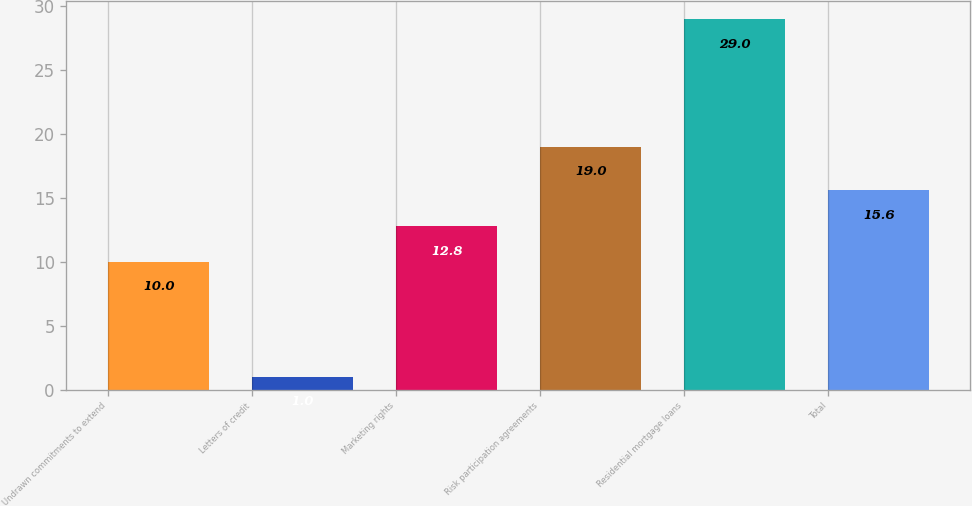Convert chart to OTSL. <chart><loc_0><loc_0><loc_500><loc_500><bar_chart><fcel>Undrawn commitments to extend<fcel>Letters of credit<fcel>Marketing rights<fcel>Risk participation agreements<fcel>Residential mortgage loans<fcel>Total<nl><fcel>10<fcel>1<fcel>12.8<fcel>19<fcel>29<fcel>15.6<nl></chart> 